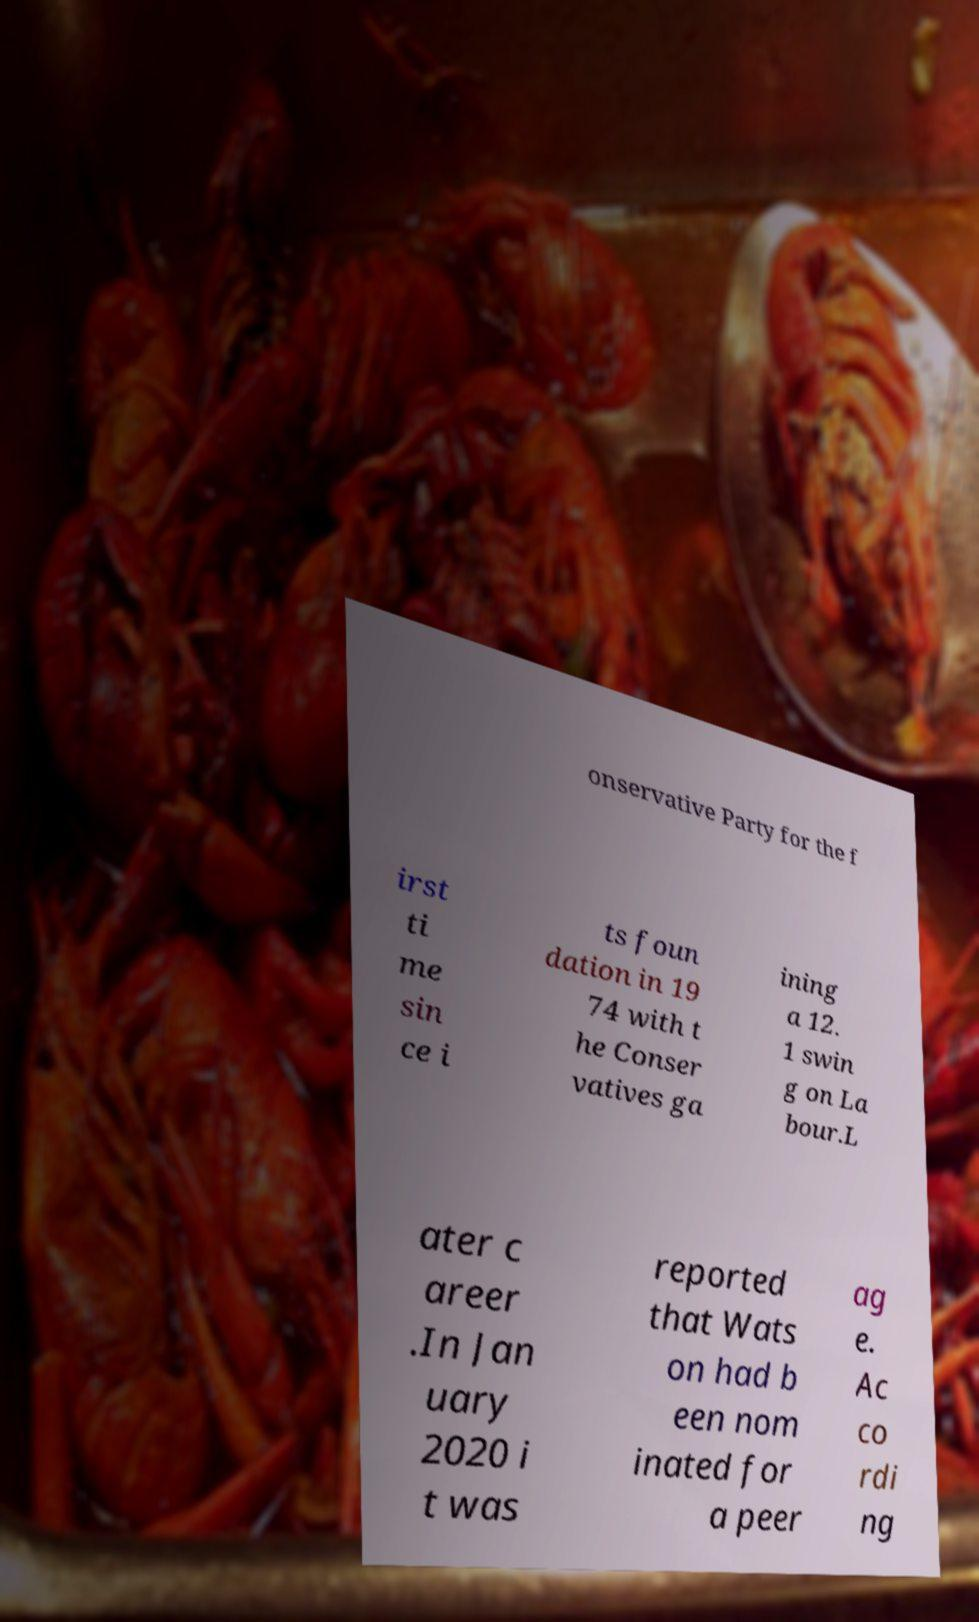Could you assist in decoding the text presented in this image and type it out clearly? onservative Party for the f irst ti me sin ce i ts foun dation in 19 74 with t he Conser vatives ga ining a 12. 1 swin g on La bour.L ater c areer .In Jan uary 2020 i t was reported that Wats on had b een nom inated for a peer ag e. Ac co rdi ng 